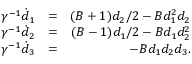Convert formula to latex. <formula><loc_0><loc_0><loc_500><loc_500>\begin{array} { r l r } { \gamma ^ { - 1 } \dot { d } _ { 1 } } & { = } & { ( B + 1 ) d _ { 2 } / 2 - B d _ { 1 } ^ { 2 } d _ { 2 } } \\ { \gamma ^ { - 1 } \dot { d } _ { 2 } } & { = } & { ( B - 1 ) d _ { 1 } / 2 - B d _ { 1 } d _ { 2 } ^ { 2 } } \\ { \gamma ^ { - 1 } \dot { d } _ { 3 } } & { = } & { - B d _ { 1 } d _ { 2 } d _ { 3 } . } \end{array}</formula> 